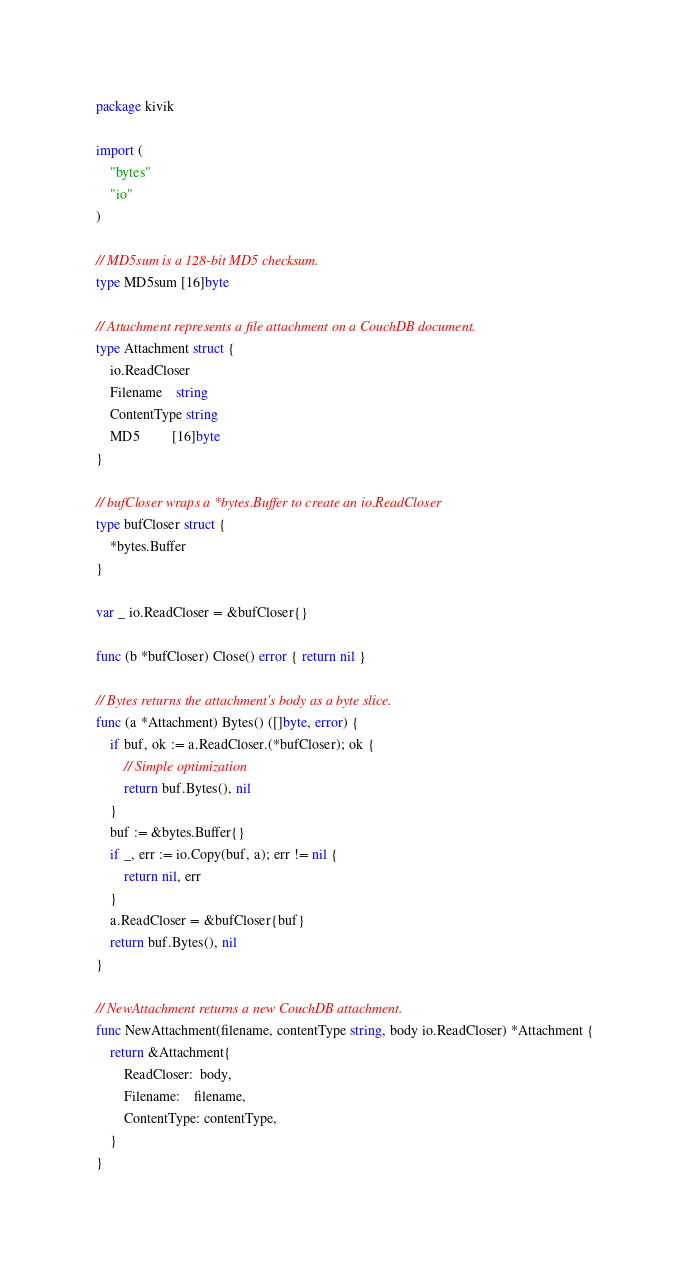Convert code to text. <code><loc_0><loc_0><loc_500><loc_500><_Go_>package kivik

import (
	"bytes"
	"io"
)

// MD5sum is a 128-bit MD5 checksum.
type MD5sum [16]byte

// Attachment represents a file attachment on a CouchDB document.
type Attachment struct {
	io.ReadCloser
	Filename    string
	ContentType string
	MD5         [16]byte
}

// bufCloser wraps a *bytes.Buffer to create an io.ReadCloser
type bufCloser struct {
	*bytes.Buffer
}

var _ io.ReadCloser = &bufCloser{}

func (b *bufCloser) Close() error { return nil }

// Bytes returns the attachment's body as a byte slice.
func (a *Attachment) Bytes() ([]byte, error) {
	if buf, ok := a.ReadCloser.(*bufCloser); ok {
		// Simple optimization
		return buf.Bytes(), nil
	}
	buf := &bytes.Buffer{}
	if _, err := io.Copy(buf, a); err != nil {
		return nil, err
	}
	a.ReadCloser = &bufCloser{buf}
	return buf.Bytes(), nil
}

// NewAttachment returns a new CouchDB attachment.
func NewAttachment(filename, contentType string, body io.ReadCloser) *Attachment {
	return &Attachment{
		ReadCloser:  body,
		Filename:    filename,
		ContentType: contentType,
	}
}
</code> 